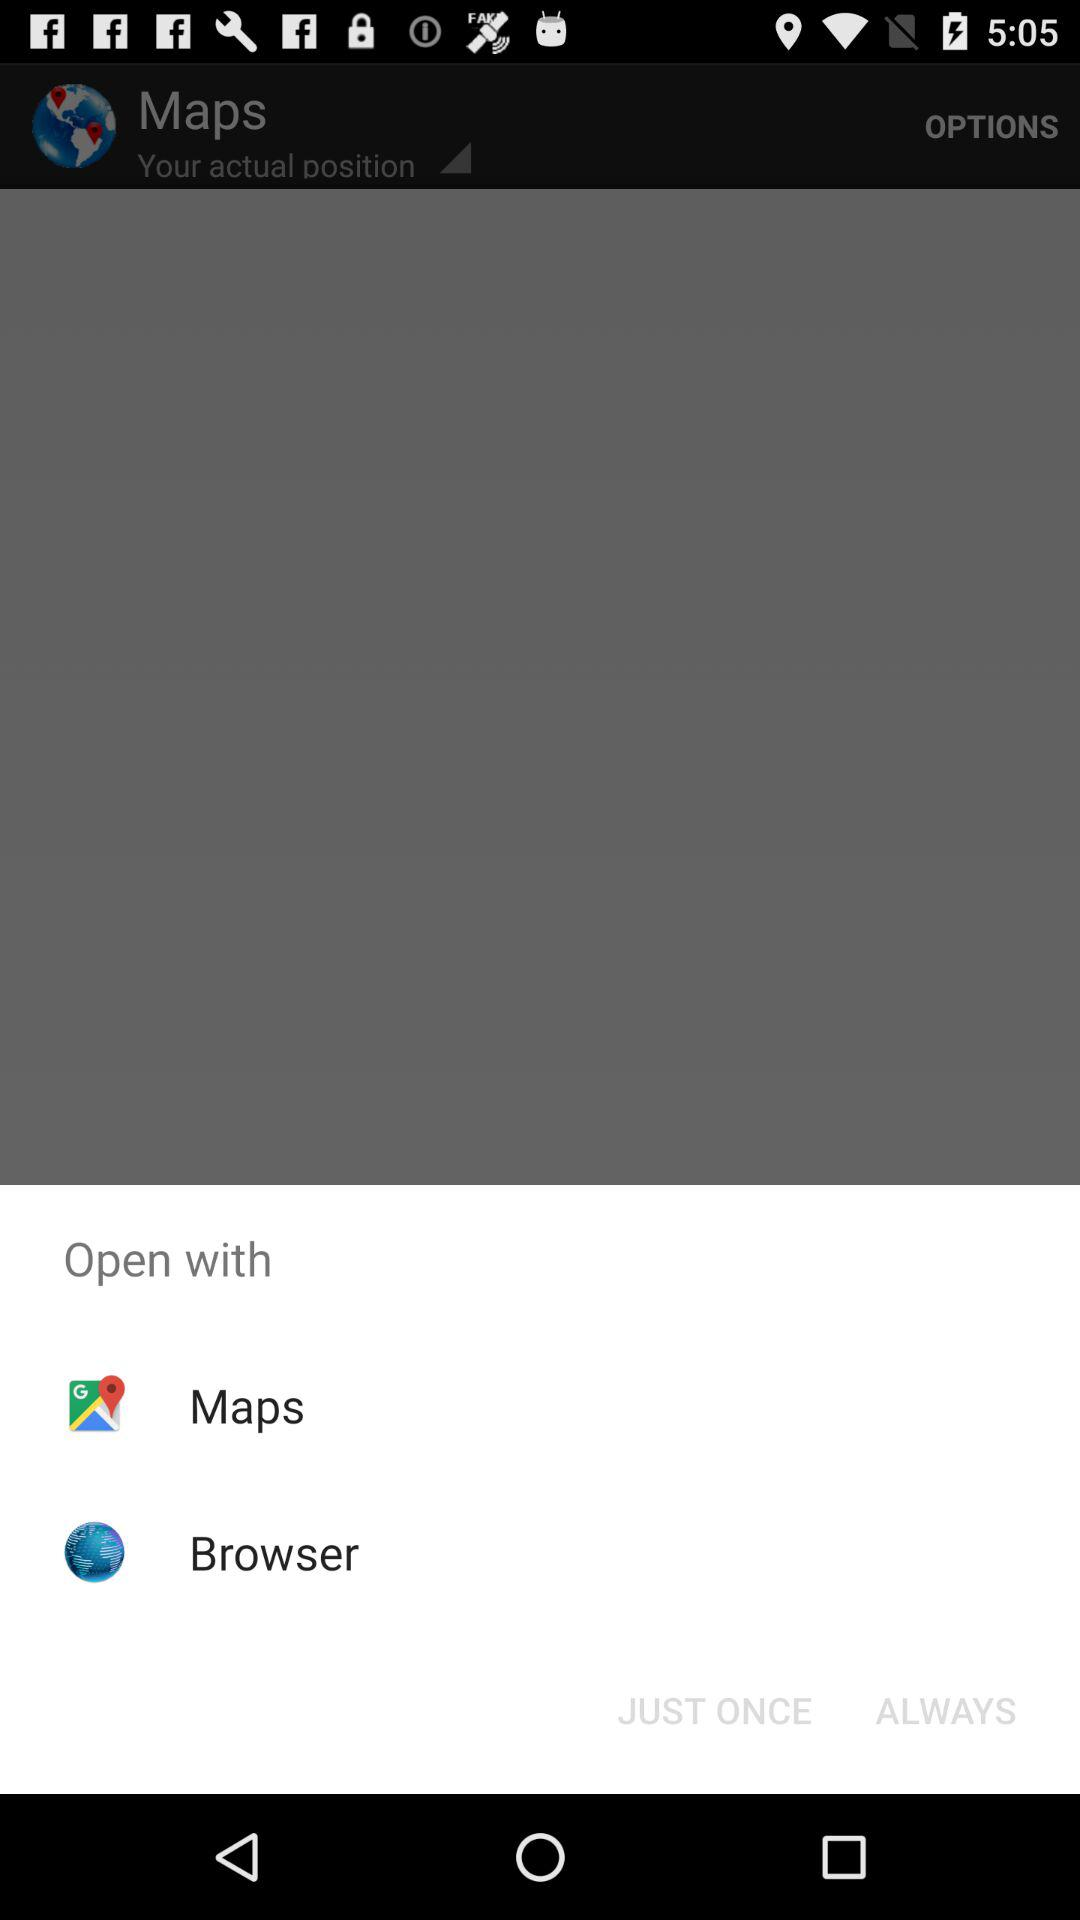What are the options given for open? You can open them with "Maps" and "Browser". 